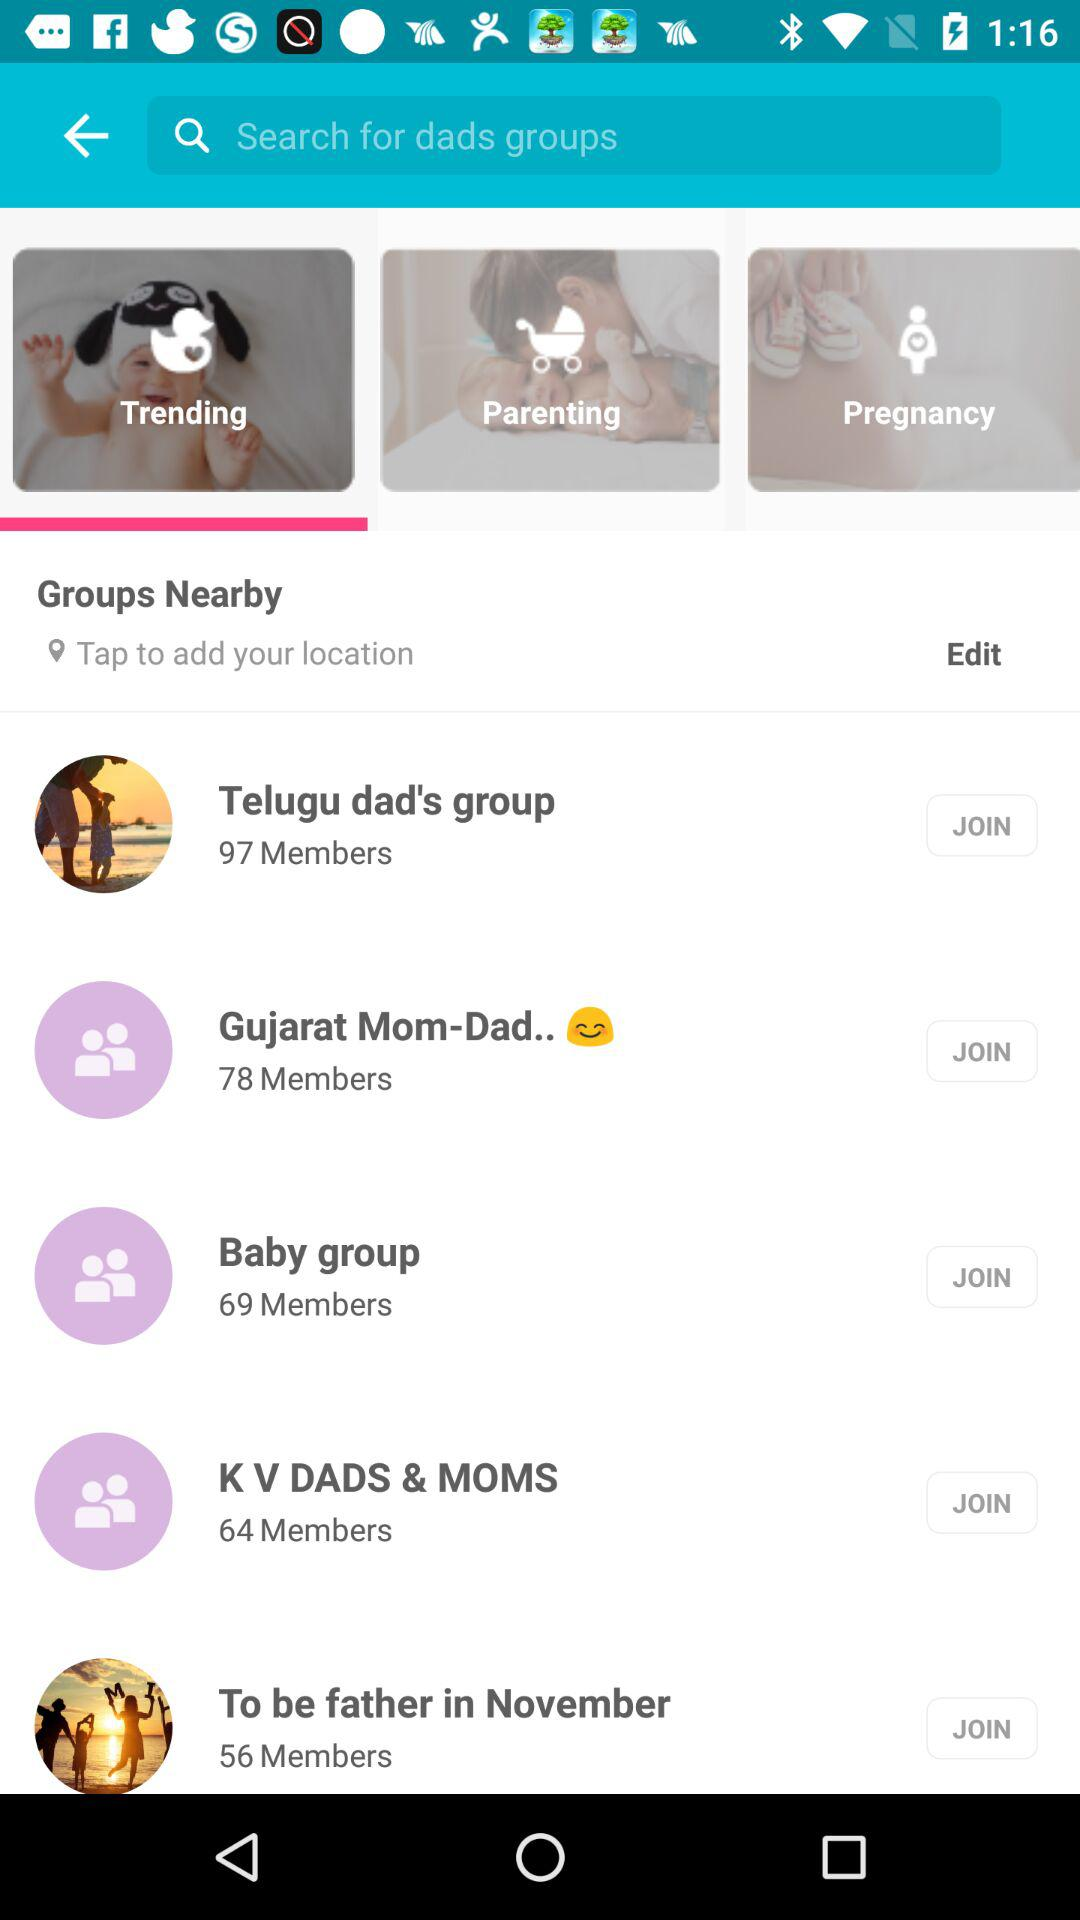What are the trending groups that can I join? You can join "Telgu dad's group", "Gujrati Mom-Dad..", "Baby group", "K V DADS & MOMS" and "To be father in November". 